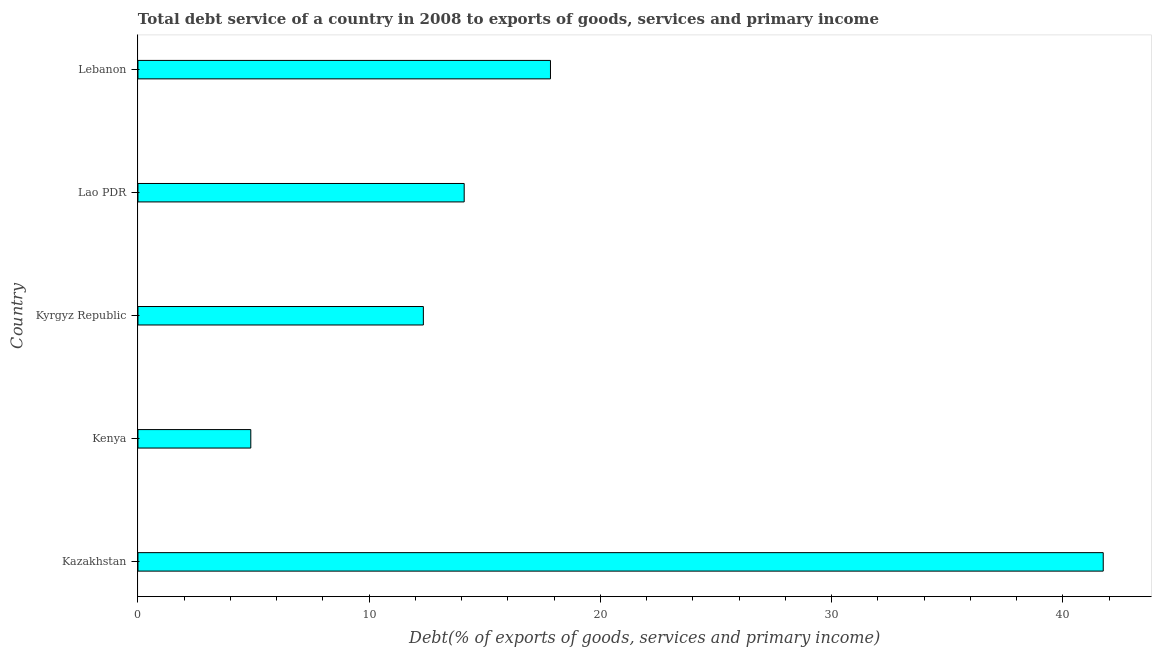What is the title of the graph?
Your answer should be compact. Total debt service of a country in 2008 to exports of goods, services and primary income. What is the label or title of the X-axis?
Offer a terse response. Debt(% of exports of goods, services and primary income). What is the label or title of the Y-axis?
Your response must be concise. Country. What is the total debt service in Kenya?
Ensure brevity in your answer.  4.88. Across all countries, what is the maximum total debt service?
Your answer should be very brief. 41.75. Across all countries, what is the minimum total debt service?
Give a very brief answer. 4.88. In which country was the total debt service maximum?
Your response must be concise. Kazakhstan. In which country was the total debt service minimum?
Your answer should be very brief. Kenya. What is the sum of the total debt service?
Ensure brevity in your answer.  90.92. What is the difference between the total debt service in Kazakhstan and Kenya?
Your answer should be very brief. 36.87. What is the average total debt service per country?
Provide a short and direct response. 18.18. What is the median total debt service?
Your response must be concise. 14.11. In how many countries, is the total debt service greater than 20 %?
Your answer should be compact. 1. What is the ratio of the total debt service in Kazakhstan to that in Lao PDR?
Provide a short and direct response. 2.96. Is the difference between the total debt service in Kenya and Kyrgyz Republic greater than the difference between any two countries?
Make the answer very short. No. What is the difference between the highest and the second highest total debt service?
Ensure brevity in your answer.  23.91. Is the sum of the total debt service in Kazakhstan and Kyrgyz Republic greater than the maximum total debt service across all countries?
Provide a short and direct response. Yes. What is the difference between the highest and the lowest total debt service?
Make the answer very short. 36.87. In how many countries, is the total debt service greater than the average total debt service taken over all countries?
Your response must be concise. 1. How many bars are there?
Provide a short and direct response. 5. How many countries are there in the graph?
Keep it short and to the point. 5. What is the difference between two consecutive major ticks on the X-axis?
Offer a very short reply. 10. Are the values on the major ticks of X-axis written in scientific E-notation?
Provide a short and direct response. No. What is the Debt(% of exports of goods, services and primary income) in Kazakhstan?
Provide a succinct answer. 41.75. What is the Debt(% of exports of goods, services and primary income) in Kenya?
Offer a very short reply. 4.88. What is the Debt(% of exports of goods, services and primary income) in Kyrgyz Republic?
Provide a succinct answer. 12.34. What is the Debt(% of exports of goods, services and primary income) of Lao PDR?
Your answer should be very brief. 14.11. What is the Debt(% of exports of goods, services and primary income) in Lebanon?
Make the answer very short. 17.84. What is the difference between the Debt(% of exports of goods, services and primary income) in Kazakhstan and Kenya?
Give a very brief answer. 36.87. What is the difference between the Debt(% of exports of goods, services and primary income) in Kazakhstan and Kyrgyz Republic?
Your answer should be very brief. 29.4. What is the difference between the Debt(% of exports of goods, services and primary income) in Kazakhstan and Lao PDR?
Provide a succinct answer. 27.64. What is the difference between the Debt(% of exports of goods, services and primary income) in Kazakhstan and Lebanon?
Give a very brief answer. 23.91. What is the difference between the Debt(% of exports of goods, services and primary income) in Kenya and Kyrgyz Republic?
Give a very brief answer. -7.46. What is the difference between the Debt(% of exports of goods, services and primary income) in Kenya and Lao PDR?
Make the answer very short. -9.23. What is the difference between the Debt(% of exports of goods, services and primary income) in Kenya and Lebanon?
Provide a short and direct response. -12.96. What is the difference between the Debt(% of exports of goods, services and primary income) in Kyrgyz Republic and Lao PDR?
Your response must be concise. -1.77. What is the difference between the Debt(% of exports of goods, services and primary income) in Kyrgyz Republic and Lebanon?
Ensure brevity in your answer.  -5.5. What is the difference between the Debt(% of exports of goods, services and primary income) in Lao PDR and Lebanon?
Make the answer very short. -3.73. What is the ratio of the Debt(% of exports of goods, services and primary income) in Kazakhstan to that in Kenya?
Give a very brief answer. 8.55. What is the ratio of the Debt(% of exports of goods, services and primary income) in Kazakhstan to that in Kyrgyz Republic?
Ensure brevity in your answer.  3.38. What is the ratio of the Debt(% of exports of goods, services and primary income) in Kazakhstan to that in Lao PDR?
Your response must be concise. 2.96. What is the ratio of the Debt(% of exports of goods, services and primary income) in Kazakhstan to that in Lebanon?
Provide a short and direct response. 2.34. What is the ratio of the Debt(% of exports of goods, services and primary income) in Kenya to that in Kyrgyz Republic?
Offer a terse response. 0.4. What is the ratio of the Debt(% of exports of goods, services and primary income) in Kenya to that in Lao PDR?
Your answer should be very brief. 0.35. What is the ratio of the Debt(% of exports of goods, services and primary income) in Kenya to that in Lebanon?
Provide a succinct answer. 0.27. What is the ratio of the Debt(% of exports of goods, services and primary income) in Kyrgyz Republic to that in Lebanon?
Your answer should be very brief. 0.69. What is the ratio of the Debt(% of exports of goods, services and primary income) in Lao PDR to that in Lebanon?
Your response must be concise. 0.79. 